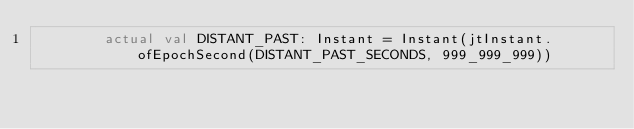<code> <loc_0><loc_0><loc_500><loc_500><_Kotlin_>        actual val DISTANT_PAST: Instant = Instant(jtInstant.ofEpochSecond(DISTANT_PAST_SECONDS, 999_999_999))</code> 